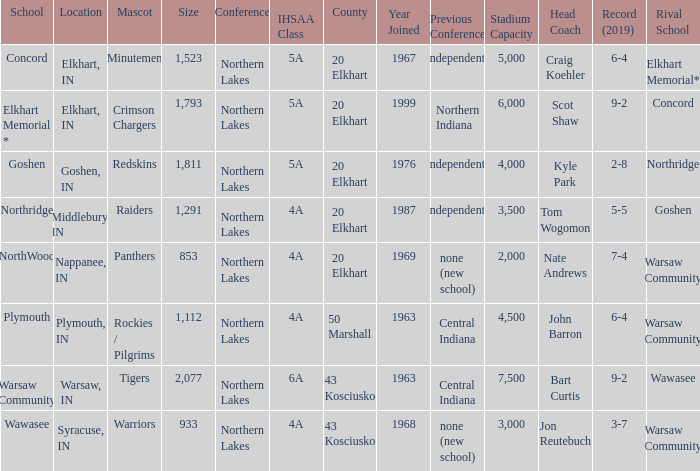What country joined before 1976, with IHSSA class of 5a, and a size larger than 1,112? 20 Elkhart. 